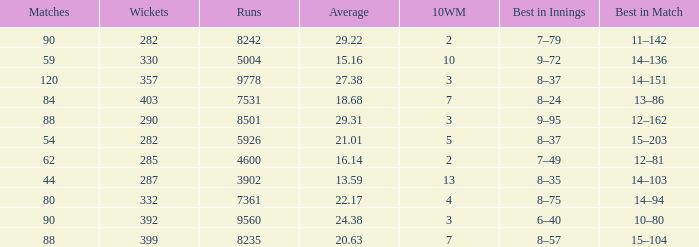What is the sum of runs that are associated with 10WM values over 13? None. 